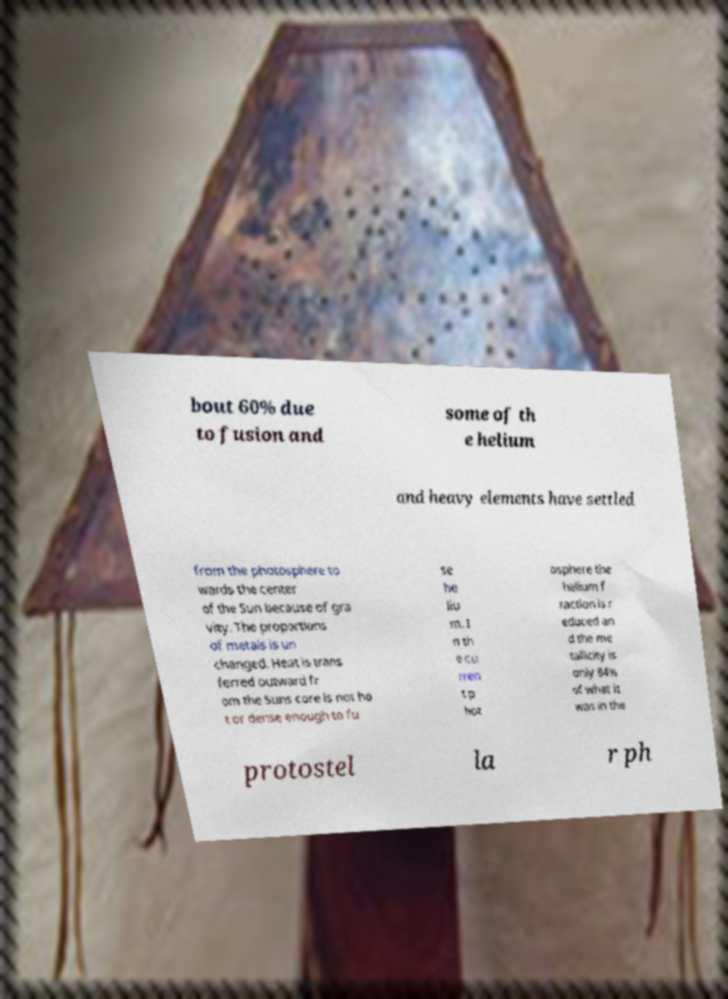Could you extract and type out the text from this image? bout 60% due to fusion and some of th e helium and heavy elements have settled from the photosphere to wards the center of the Sun because of gra vity. The proportions of metals is un changed. Heat is trans ferred outward fr om the Suns core is not ho t or dense enough to fu se he liu m. I n th e cu rren t p hot osphere the helium f raction is r educed an d the me tallicity is only 84% of what it was in the protostel la r ph 